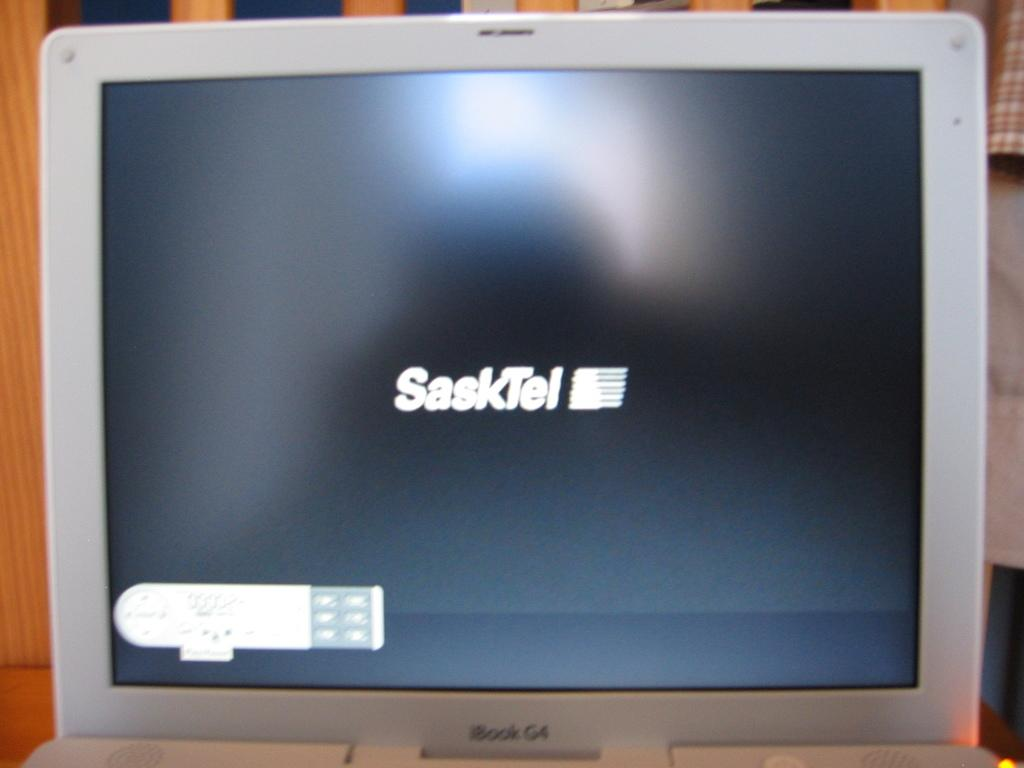<image>
Create a compact narrative representing the image presented. An iBook screen displays SaskTel in the middle of it. 